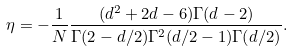<formula> <loc_0><loc_0><loc_500><loc_500>\eta = - \frac { 1 } { N } \frac { ( d ^ { 2 } + 2 d - 6 ) \Gamma ( d - 2 ) } { \Gamma ( 2 - d / 2 ) \Gamma ^ { 2 } ( d / 2 - 1 ) \Gamma ( d / 2 ) } .</formula> 